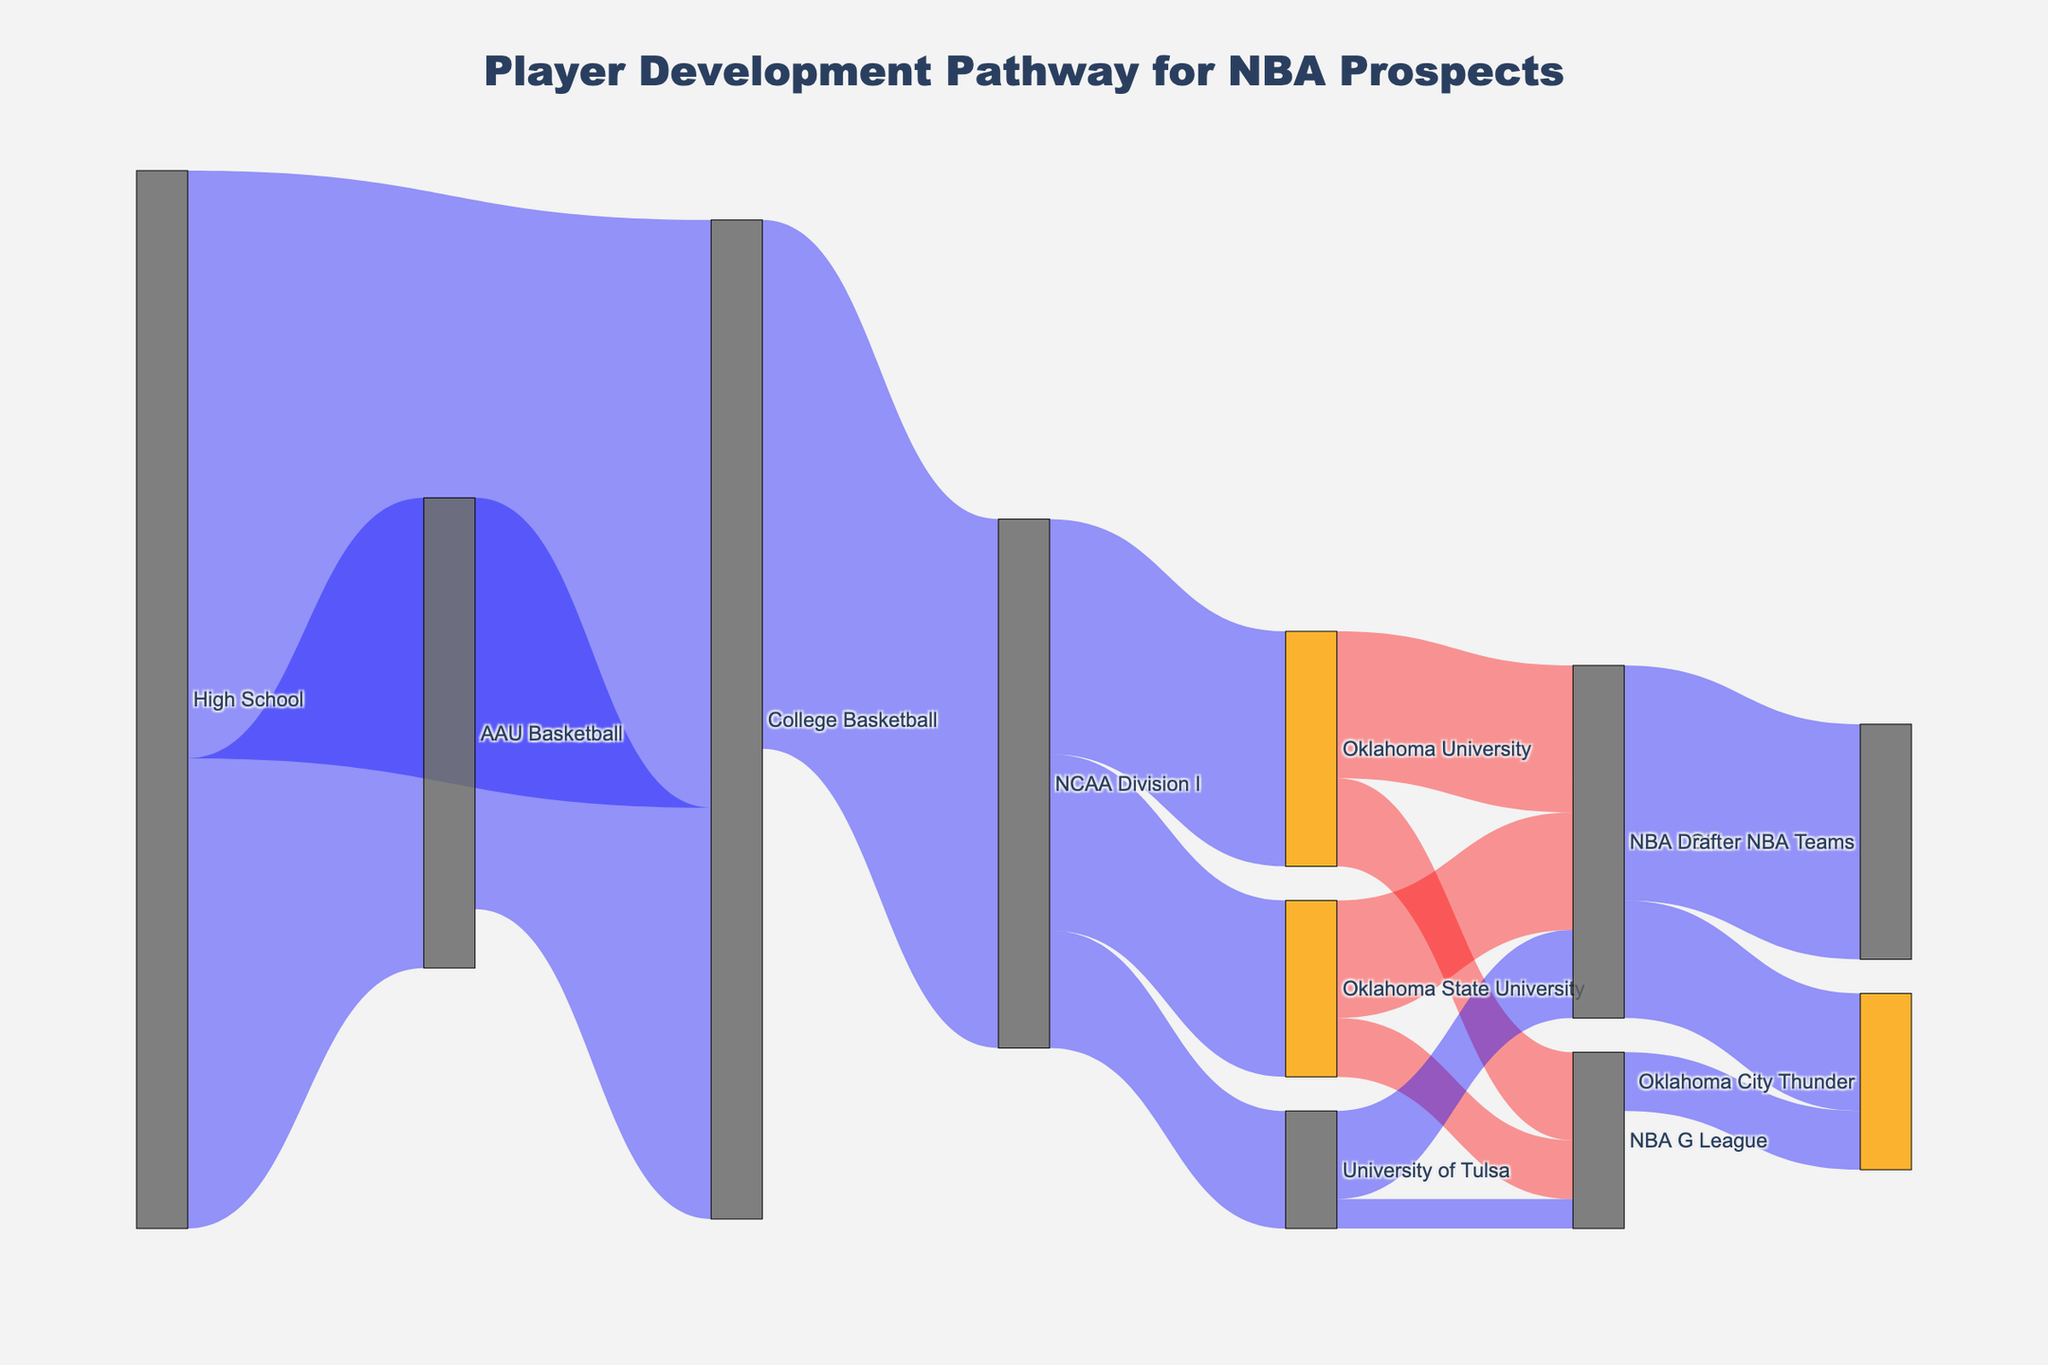What is the main pathway from High School to the NBA Draft? The figure shows pathways with connections and values between each step. From High School, many players go to AAU Basketball or College Basketball. From College Basketball, they advance to NCAA Division I, then either go to Oklahoma University, Oklahoma State University, or University of Tulsa, and eventually to the NBA Draft.
Answer: High School -> College Basketball -> NCAA Division I -> Oklahoma University/Oklahoma State University/University of Tulsa -> NBA Draft Which university has the most players advancing to the NBA Draft? By observing the diagram, follow the pathway from NCAA Division I to the NBA Draft for Oklahoma University, Oklahoma State University, and University of Tulsa. Oklahoma University has the highest value, followed by Oklahoma State University and University of Tulsa.
Answer: Oklahoma University How many players go directly from High School to College Basketball? Look at the connection between High School and College Basketball, which has a value indicating the number of players. The value is 100.
Answer: 100 What is the total number of players who advance from High School? Sum the values of all pathways from High School: to AAU Basketball and to College Basketball. The values are 80 and 100, respectively. 80 + 100 = 180.
Answer: 180 Which pathway has the least number of players? Examine the values on all the connections between nodes in the diagram. The pathway from University of Tulsa to NBA G League has the lowest value, which is 5.
Answer: University of Tulsa -> NBA G League How many players make it to the Oklahoma City Thunder from the NBA Draft? Observe the value on the connection from the NBA Draft to the Oklahoma City Thunder. The value is 20.
Answer: 20 What is the ratio of players from Oklahoma University who go to the NBA Draft compared to those who go to the NBA G League? From the diagram, count the values from Oklahoma University to the NBA Draft and to the NBA G League. The values are 25 to the Draft and 15 to the G League. So, the ratio is 25:15, which simplifies to 5:3.
Answer: 5:3 Compare the number of players advancing from Oklahoma State University to the NBA Draft and NBA G League. From the diagram, the value from Oklahoma State University to the NBA Draft is 20, and the value to the NBA G League is 10. Hence, 20 is greater than 10.
Answer: More to the NBA Draft How many players ultimately make it to the Oklahoma City Thunder? Sum the pathways leading to the Oklahoma City Thunder from both the NBA Draft and the NBA G League. The values are 20 from the NBA Draft and 10 from the NBA G League. 20 + 10 = 30.
Answer: 30 Which step in the pathway has the most transitions? Review the nodes with the highest number of incoming or outgoing connections. College Basketball has the most transitions from High School (100) and to NCAA Division I (70), which sums up to multiple transitions.
Answer: College Basketball 